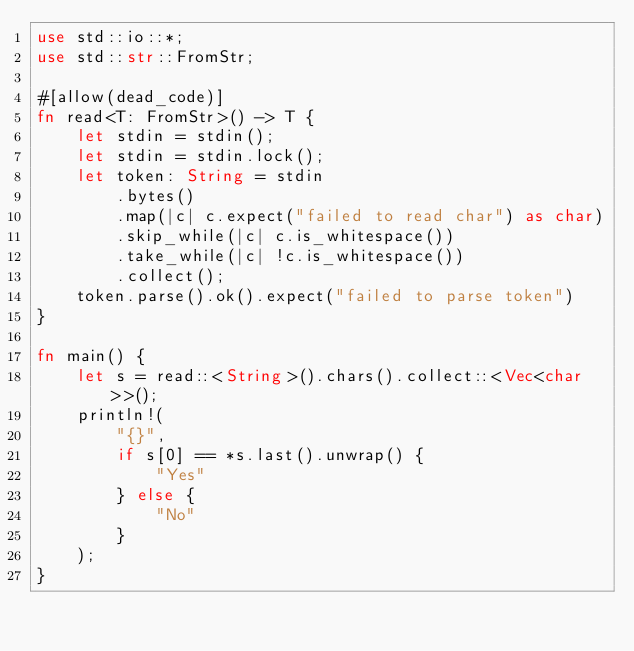Convert code to text. <code><loc_0><loc_0><loc_500><loc_500><_Rust_>use std::io::*;
use std::str::FromStr;

#[allow(dead_code)]
fn read<T: FromStr>() -> T {
    let stdin = stdin();
    let stdin = stdin.lock();
    let token: String = stdin
        .bytes()
        .map(|c| c.expect("failed to read char") as char)
        .skip_while(|c| c.is_whitespace())
        .take_while(|c| !c.is_whitespace())
        .collect();
    token.parse().ok().expect("failed to parse token")
}

fn main() {
    let s = read::<String>().chars().collect::<Vec<char>>();
    println!(
        "{}",
        if s[0] == *s.last().unwrap() {
            "Yes"
        } else {
            "No"
        }
    );
}
</code> 